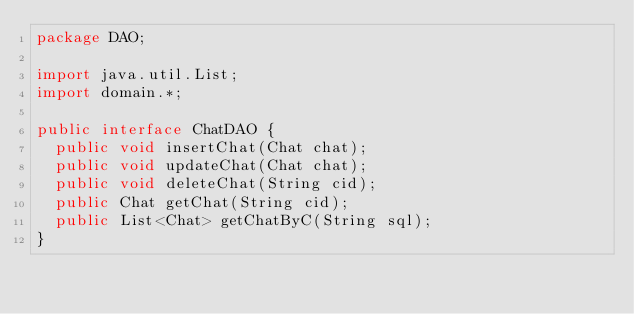Convert code to text. <code><loc_0><loc_0><loc_500><loc_500><_Java_>package DAO;

import java.util.List;
import domain.*;

public interface ChatDAO {
	public void insertChat(Chat chat);
	public void updateChat(Chat chat);
	public void deleteChat(String cid);
	public Chat getChat(String cid);
	public List<Chat> getChatByC(String sql);
}
</code> 